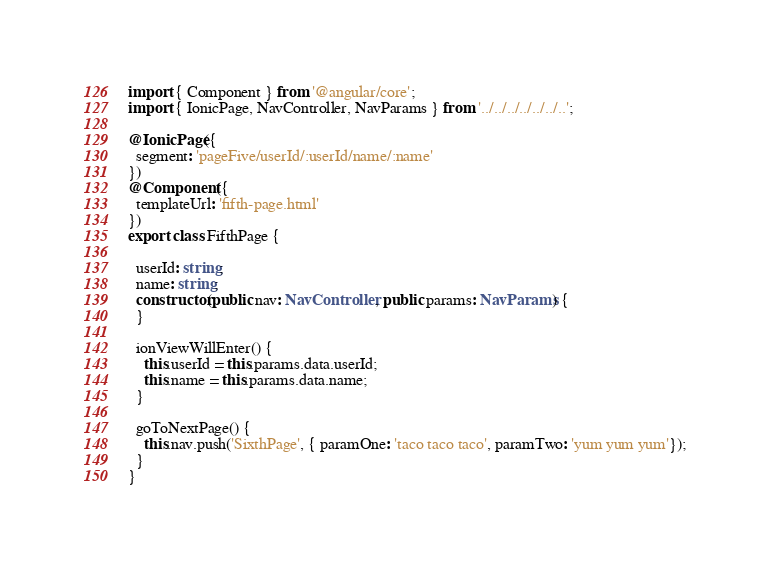<code> <loc_0><loc_0><loc_500><loc_500><_TypeScript_>import { Component } from '@angular/core';
import { IonicPage, NavController, NavParams } from '../../../../../../..';

@IonicPage({
  segment: 'pageFive/userId/:userId/name/:name'
})
@Component({
  templateUrl: 'fifth-page.html'
})
export class FifthPage {

  userId: string;
  name: string;
  constructor(public nav: NavController, public params: NavParams) {
  }

  ionViewWillEnter() {
    this.userId = this.params.data.userId;
    this.name = this.params.data.name;
  }

  goToNextPage() {
    this.nav.push('SixthPage', { paramOne: 'taco taco taco', paramTwo: 'yum yum yum'});
  }
}
</code> 